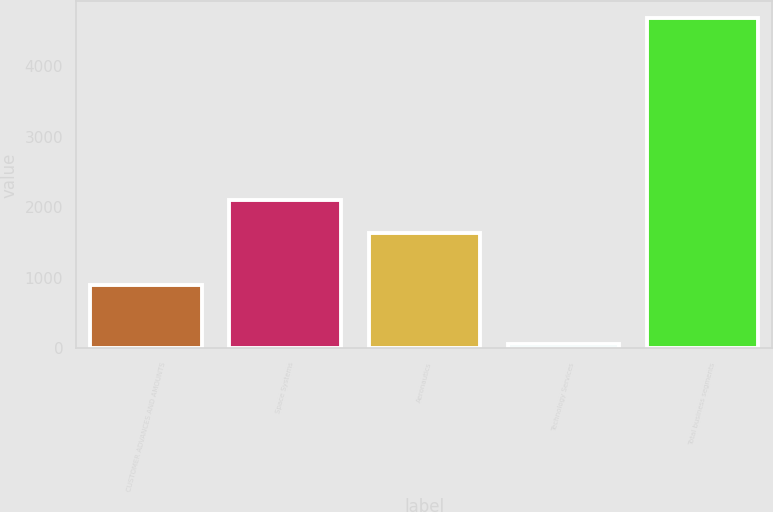<chart> <loc_0><loc_0><loc_500><loc_500><bar_chart><fcel>CUSTOMER ADVANCES AND AMOUNTS<fcel>Space Systems<fcel>Aeronautics<fcel>Technology Services<fcel>Total business segments<nl><fcel>899<fcel>2098.2<fcel>1636<fcel>60<fcel>4682<nl></chart> 